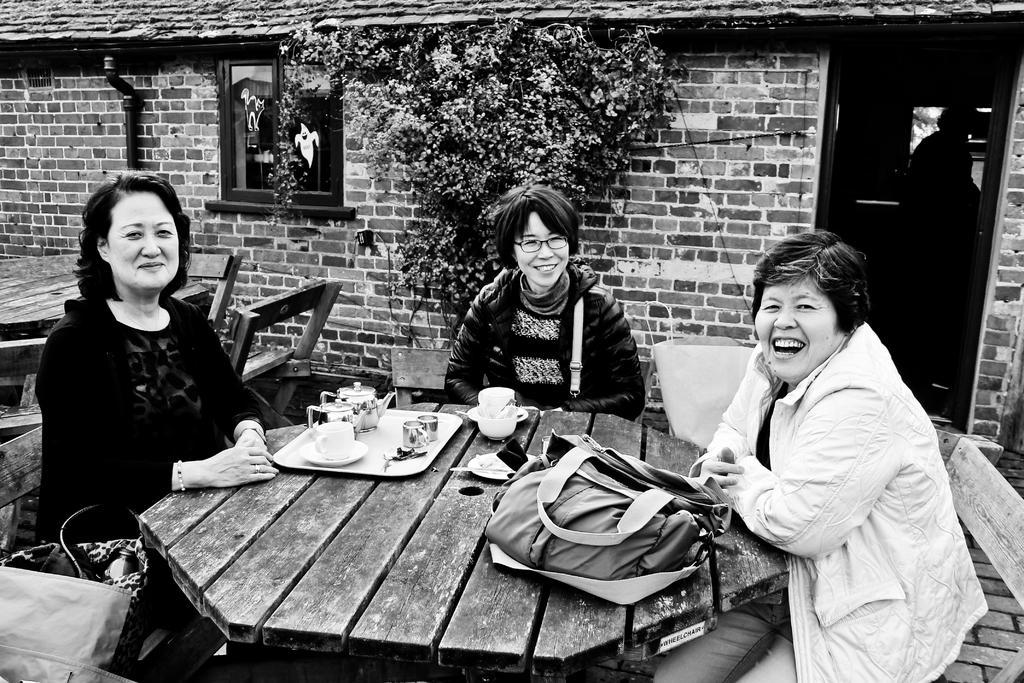Describe this image in one or two sentences. Here we can see 3 woman sitting on chairs at the table in front of them there is a plate and cups and kettle there is a bag in front of the woman who is sitting in the right and all the three women are laughing and behind them we can see a house and we can see a window and beside that we can see a plant 